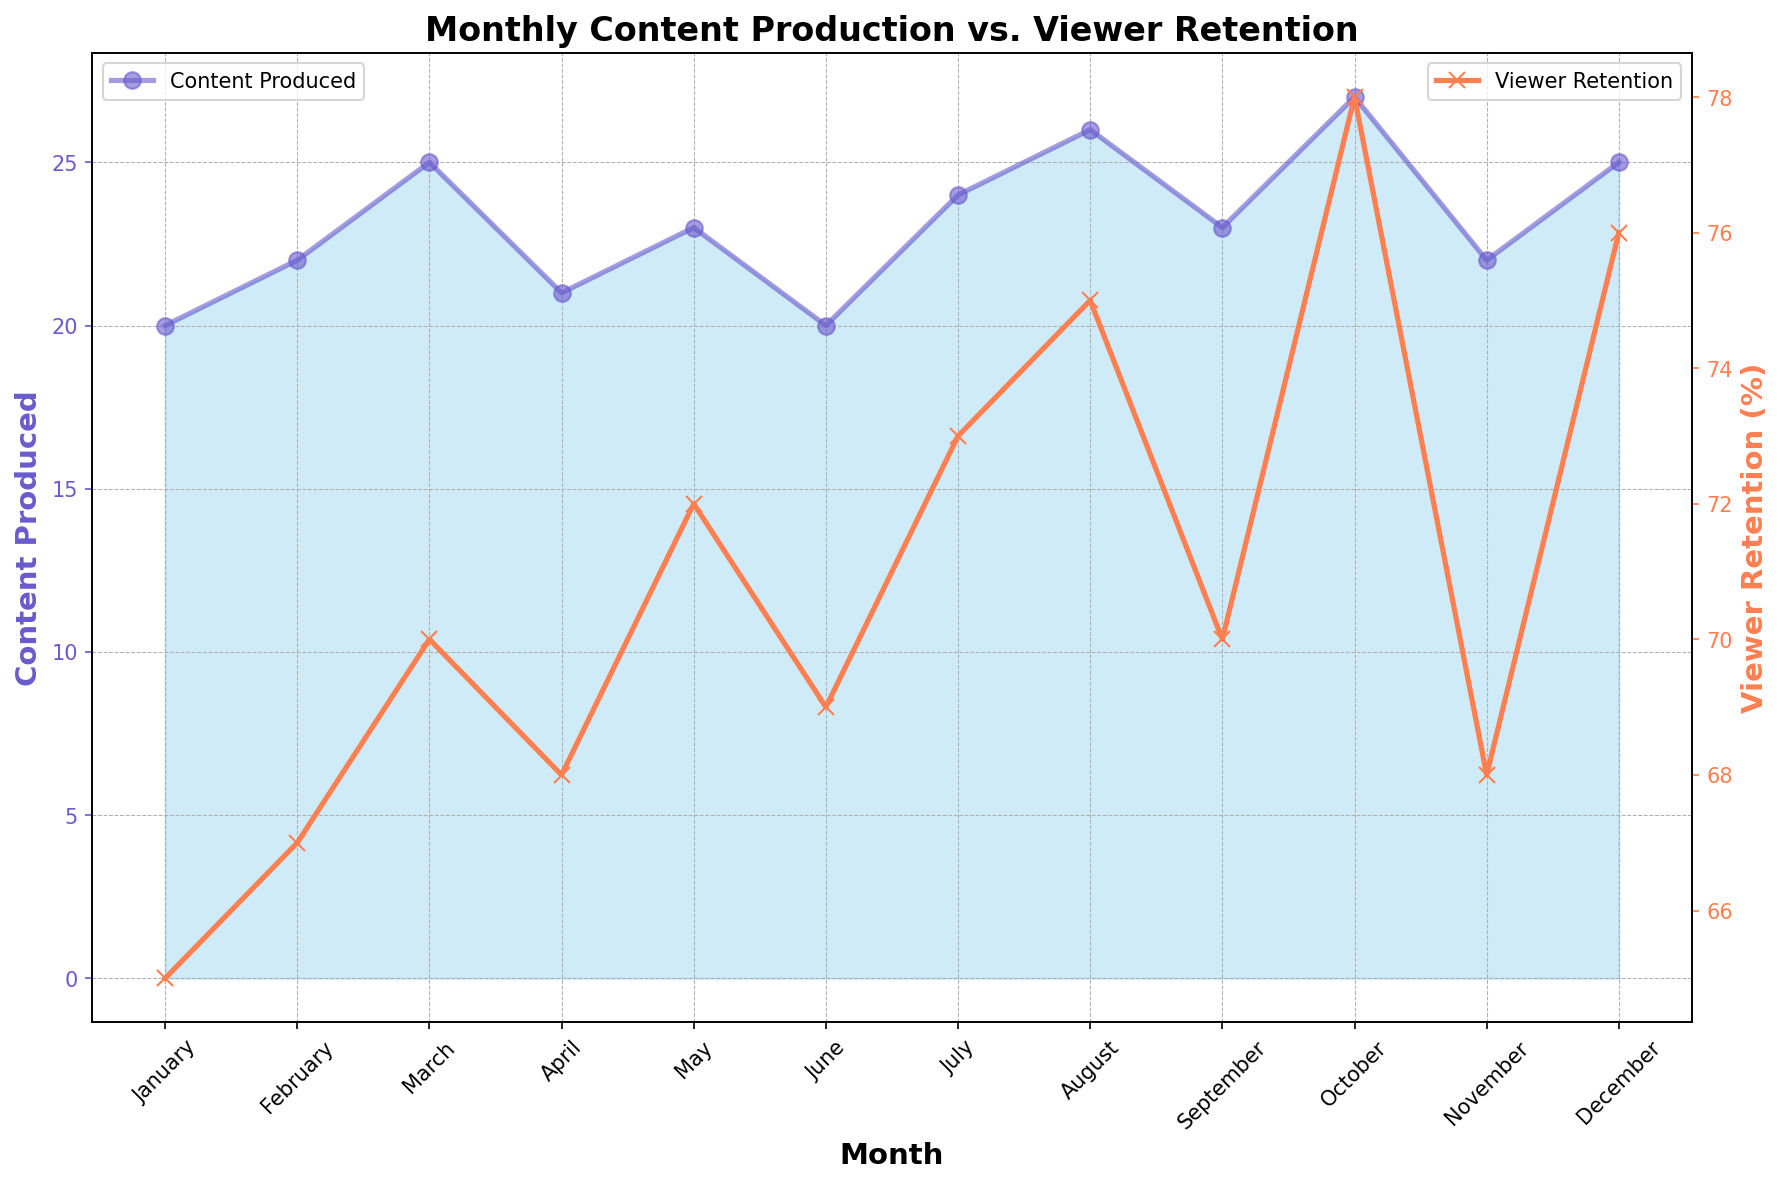What's the month with the highest viewer retention? The viewer retention line reaches its peak value in October, as shown by the marked point on the coral-colored line.
Answer: October Which month had the lowest content produced and what was the viewer retention for that month? The content production is at its lowest in January and June with a value of 20. The corresponding viewer retention for these months is shown as 65 for January and 69 for June on the secondary y-axis.
Answer: January, 65; June, 69 Compare the content produced in March and November. Which month had higher production and by how much? In March, the content produced is 25, while in November, it is 22. The difference can be calculated as 25 - 22.
Answer: March by 3 What’s the total number of content produced over the entire year? Sum the values for each month: 20 + 22 + 25 + 21 + 23 + 20 + 24 + 26 + 23 + 27 + 22 + 25 = 278
Answer: 278 How many months had viewer retention above 70%? The viewer retention exceeds 70% in May, July, August, October, and December. Count these months.
Answer: 5 In which month does the viewer retention trend begin to noticeably exceed 70% and continually stay above it? The viewer retention exceeds 70% in May and continues to stay above 70%, except for a slight drop in September and November.
Answer: May Which month showed the largest increase in content produced compared to the previous month? Compare the month-to-month changes: February-March (22-25=3), March-April (25-21=-4), April-May (21-23=2), etc. The largest increase is observed between September (23) and October (27), which is an increase of 4.
Answer: October Is there a visible trend between the amount of content produced and viewer retention over the months? Generally, as more content is produced, viewer retention increases, with notable peaks in viewer retention corresponding to higher content production months such as August and October.
Answer: Yes Which month had the lowest viewer retention percentage and what was the corresponding content produced? January had the lowest retention of 65%, and the corresponding content produced was 20.
Answer: January, 20 